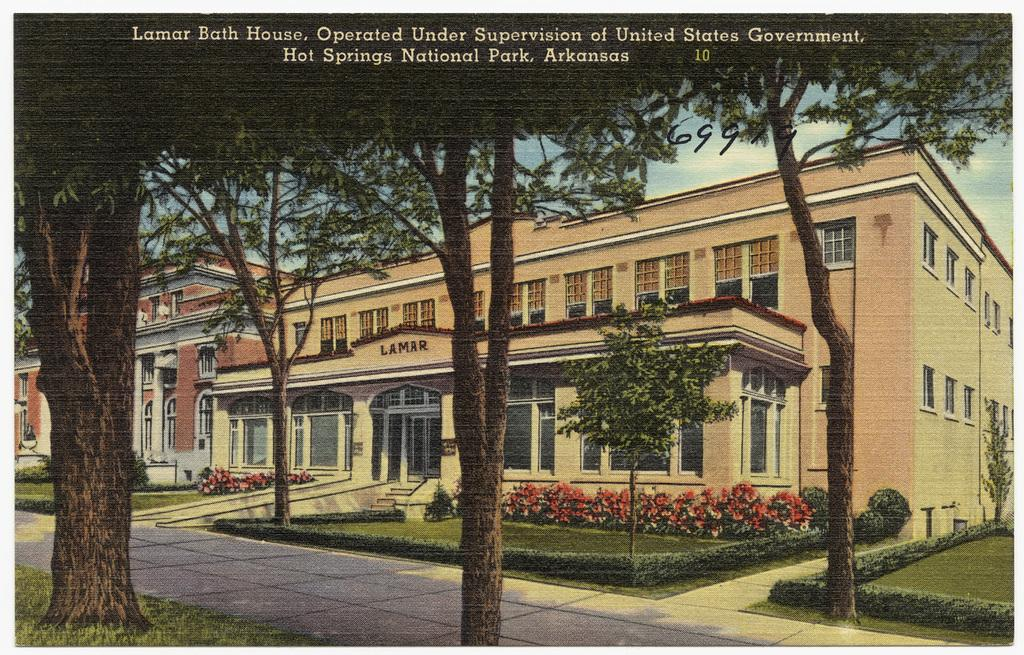What is the main subject of the poster in the image? The poster contains images of buildings, trees, plants, and grass. What type of structures are depicted on the poster? The poster contains images of buildings. What type of vegetation is depicted on the poster? The poster contains images of trees and plants. What type of landscape feature is depicted on the poster? The poster contains images of grass. Can you tell me where the drawer is located on the poster? There is no drawer present on the poster; it contains images of buildings, trees, plants, and grass. What type of home is shown in the image? The image does not depict a home; it is a poster with images of buildings, trees, plants, and grass. 